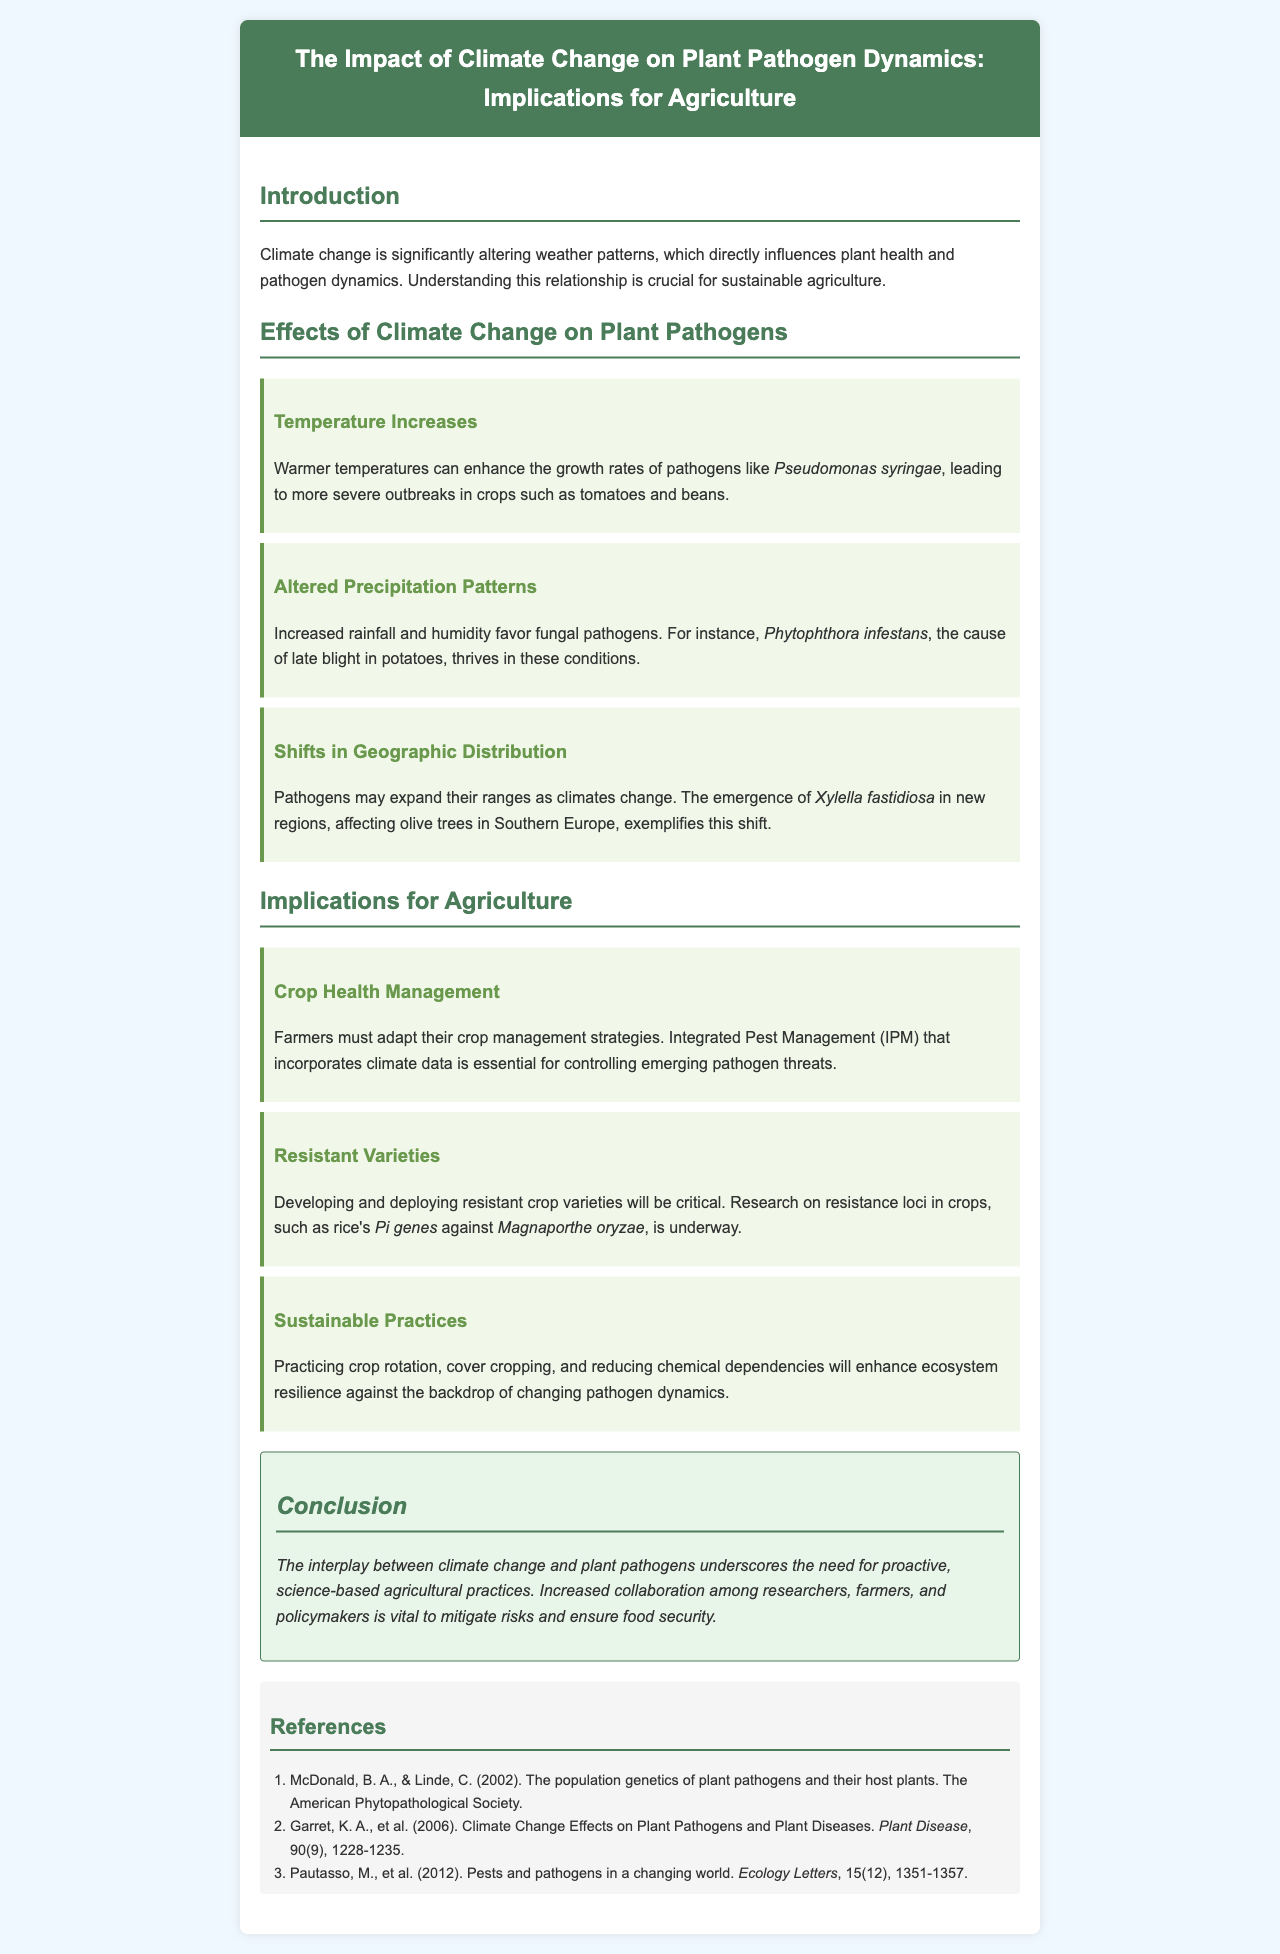What is the title of the brochure? The title of the brochure is stated at the top of the document.
Answer: The Impact of Climate Change on Plant Pathogen Dynamics: Implications for Agriculture What pathogen is mentioned as thriving in increased rainfall conditions? The document presents a specific example of a pathogen in a subsection about altered precipitation patterns.
Answer: Phytophthora infestans Which crop is affected by the pathogen Pseudomonas syringae? The document specifies a crop affected by this pathogen in the section about temperature increases.
Answer: Tomatoes and beans What management strategy is recommended for farmers? The brochure suggests a specific strategy in the implications for agriculture section regarding crop management.
Answer: Integrated Pest Management (IPM) What is the focus of ongoing research mentioned in the brochure? The text highlights a specific area of research related to resistant crop varieties.
Answer: Resistance loci in crops 